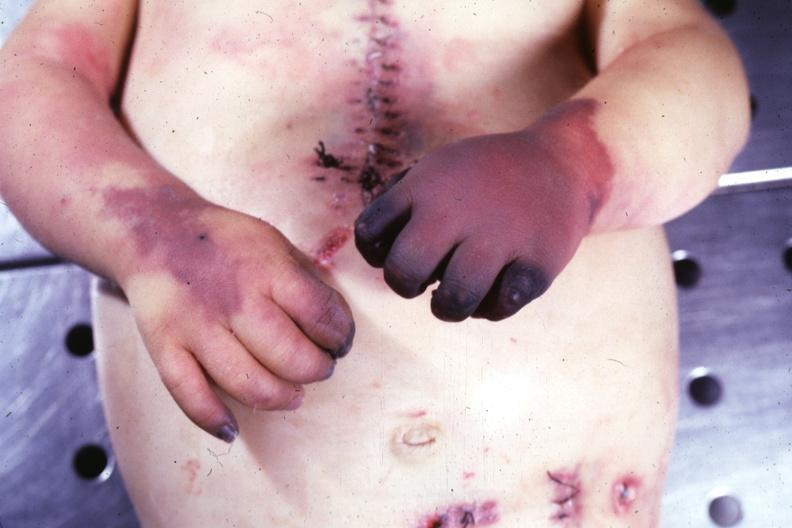re nodules present?
Answer the question using a single word or phrase. No 